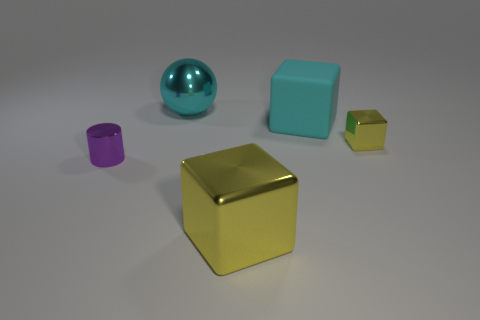Add 3 small blocks. How many objects exist? 8 Subtract all large cyan blocks. How many blocks are left? 2 Subtract 0 gray spheres. How many objects are left? 5 Subtract all cubes. How many objects are left? 2 Subtract 1 balls. How many balls are left? 0 Subtract all green blocks. Subtract all purple cylinders. How many blocks are left? 3 Subtract all purple spheres. How many yellow cubes are left? 2 Subtract all yellow matte balls. Subtract all rubber objects. How many objects are left? 4 Add 5 large metallic balls. How many large metallic balls are left? 6 Add 5 tiny yellow cubes. How many tiny yellow cubes exist? 6 